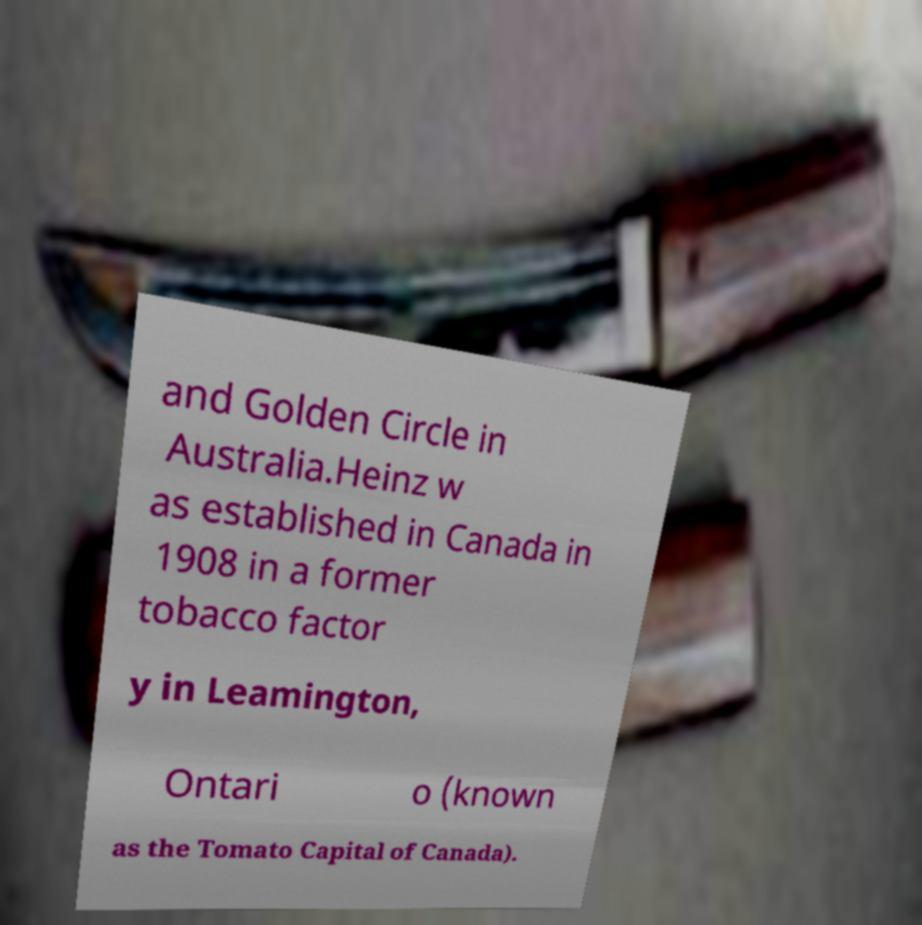Can you accurately transcribe the text from the provided image for me? and Golden Circle in Australia.Heinz w as established in Canada in 1908 in a former tobacco factor y in Leamington, Ontari o (known as the Tomato Capital of Canada). 